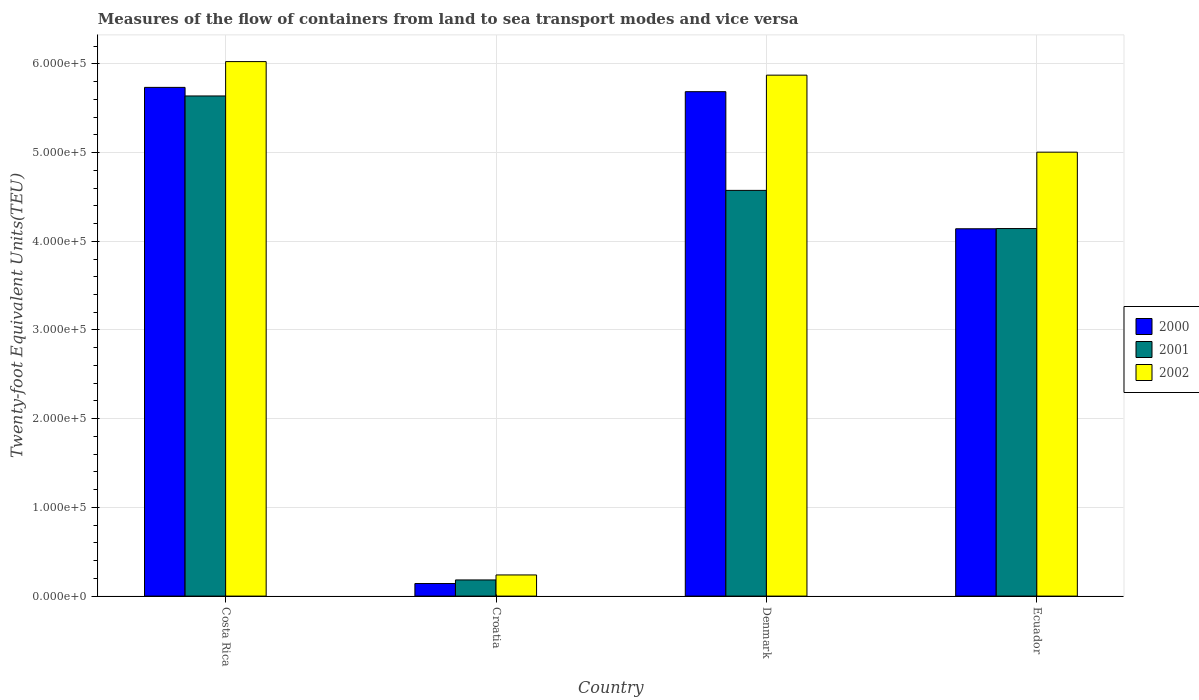How many different coloured bars are there?
Your answer should be very brief. 3. Are the number of bars on each tick of the X-axis equal?
Offer a very short reply. Yes. How many bars are there on the 2nd tick from the left?
Ensure brevity in your answer.  3. What is the label of the 1st group of bars from the left?
Provide a succinct answer. Costa Rica. In how many cases, is the number of bars for a given country not equal to the number of legend labels?
Give a very brief answer. 0. What is the container port traffic in 2000 in Costa Rica?
Your response must be concise. 5.74e+05. Across all countries, what is the maximum container port traffic in 2001?
Offer a very short reply. 5.64e+05. Across all countries, what is the minimum container port traffic in 2000?
Offer a very short reply. 1.42e+04. In which country was the container port traffic in 2000 maximum?
Provide a short and direct response. Costa Rica. In which country was the container port traffic in 2000 minimum?
Provide a succinct answer. Croatia. What is the total container port traffic in 2000 in the graph?
Offer a terse response. 1.57e+06. What is the difference between the container port traffic in 2002 in Croatia and that in Denmark?
Your answer should be very brief. -5.63e+05. What is the difference between the container port traffic in 2002 in Costa Rica and the container port traffic in 2001 in Croatia?
Provide a succinct answer. 5.84e+05. What is the average container port traffic in 2000 per country?
Ensure brevity in your answer.  3.93e+05. What is the difference between the container port traffic of/in 2002 and container port traffic of/in 2000 in Croatia?
Offer a very short reply. 9700. In how many countries, is the container port traffic in 2000 greater than 540000 TEU?
Your answer should be very brief. 2. What is the ratio of the container port traffic in 2001 in Croatia to that in Denmark?
Your answer should be compact. 0.04. Is the container port traffic in 2001 in Croatia less than that in Denmark?
Ensure brevity in your answer.  Yes. What is the difference between the highest and the second highest container port traffic in 2002?
Provide a succinct answer. 1.53e+04. What is the difference between the highest and the lowest container port traffic in 2000?
Ensure brevity in your answer.  5.59e+05. In how many countries, is the container port traffic in 2001 greater than the average container port traffic in 2001 taken over all countries?
Provide a succinct answer. 3. Is it the case that in every country, the sum of the container port traffic in 2002 and container port traffic in 2000 is greater than the container port traffic in 2001?
Your response must be concise. Yes. How many bars are there?
Your answer should be compact. 12. Are all the bars in the graph horizontal?
Give a very brief answer. No. How many countries are there in the graph?
Your response must be concise. 4. What is the difference between two consecutive major ticks on the Y-axis?
Ensure brevity in your answer.  1.00e+05. Are the values on the major ticks of Y-axis written in scientific E-notation?
Provide a succinct answer. Yes. Where does the legend appear in the graph?
Your response must be concise. Center right. How many legend labels are there?
Ensure brevity in your answer.  3. How are the legend labels stacked?
Make the answer very short. Vertical. What is the title of the graph?
Give a very brief answer. Measures of the flow of containers from land to sea transport modes and vice versa. Does "1992" appear as one of the legend labels in the graph?
Ensure brevity in your answer.  No. What is the label or title of the Y-axis?
Keep it short and to the point. Twenty-foot Equivalent Units(TEU). What is the Twenty-foot Equivalent Units(TEU) of 2000 in Costa Rica?
Make the answer very short. 5.74e+05. What is the Twenty-foot Equivalent Units(TEU) in 2001 in Costa Rica?
Offer a terse response. 5.64e+05. What is the Twenty-foot Equivalent Units(TEU) of 2002 in Costa Rica?
Make the answer very short. 6.03e+05. What is the Twenty-foot Equivalent Units(TEU) of 2000 in Croatia?
Your response must be concise. 1.42e+04. What is the Twenty-foot Equivalent Units(TEU) of 2001 in Croatia?
Give a very brief answer. 1.82e+04. What is the Twenty-foot Equivalent Units(TEU) in 2002 in Croatia?
Offer a very short reply. 2.39e+04. What is the Twenty-foot Equivalent Units(TEU) in 2000 in Denmark?
Provide a short and direct response. 5.69e+05. What is the Twenty-foot Equivalent Units(TEU) in 2001 in Denmark?
Your response must be concise. 4.57e+05. What is the Twenty-foot Equivalent Units(TEU) of 2002 in Denmark?
Provide a short and direct response. 5.87e+05. What is the Twenty-foot Equivalent Units(TEU) of 2000 in Ecuador?
Your answer should be very brief. 4.14e+05. What is the Twenty-foot Equivalent Units(TEU) of 2001 in Ecuador?
Ensure brevity in your answer.  4.14e+05. What is the Twenty-foot Equivalent Units(TEU) in 2002 in Ecuador?
Give a very brief answer. 5.00e+05. Across all countries, what is the maximum Twenty-foot Equivalent Units(TEU) of 2000?
Your answer should be very brief. 5.74e+05. Across all countries, what is the maximum Twenty-foot Equivalent Units(TEU) in 2001?
Offer a very short reply. 5.64e+05. Across all countries, what is the maximum Twenty-foot Equivalent Units(TEU) in 2002?
Give a very brief answer. 6.03e+05. Across all countries, what is the minimum Twenty-foot Equivalent Units(TEU) of 2000?
Offer a terse response. 1.42e+04. Across all countries, what is the minimum Twenty-foot Equivalent Units(TEU) of 2001?
Keep it short and to the point. 1.82e+04. Across all countries, what is the minimum Twenty-foot Equivalent Units(TEU) of 2002?
Your answer should be very brief. 2.39e+04. What is the total Twenty-foot Equivalent Units(TEU) in 2000 in the graph?
Your answer should be very brief. 1.57e+06. What is the total Twenty-foot Equivalent Units(TEU) in 2001 in the graph?
Offer a very short reply. 1.45e+06. What is the total Twenty-foot Equivalent Units(TEU) of 2002 in the graph?
Offer a terse response. 1.71e+06. What is the difference between the Twenty-foot Equivalent Units(TEU) in 2000 in Costa Rica and that in Croatia?
Make the answer very short. 5.59e+05. What is the difference between the Twenty-foot Equivalent Units(TEU) of 2001 in Costa Rica and that in Croatia?
Give a very brief answer. 5.46e+05. What is the difference between the Twenty-foot Equivalent Units(TEU) in 2002 in Costa Rica and that in Croatia?
Provide a short and direct response. 5.79e+05. What is the difference between the Twenty-foot Equivalent Units(TEU) of 2000 in Costa Rica and that in Denmark?
Keep it short and to the point. 4842. What is the difference between the Twenty-foot Equivalent Units(TEU) in 2001 in Costa Rica and that in Denmark?
Ensure brevity in your answer.  1.06e+05. What is the difference between the Twenty-foot Equivalent Units(TEU) in 2002 in Costa Rica and that in Denmark?
Make the answer very short. 1.53e+04. What is the difference between the Twenty-foot Equivalent Units(TEU) in 2000 in Costa Rica and that in Ecuador?
Provide a short and direct response. 1.59e+05. What is the difference between the Twenty-foot Equivalent Units(TEU) of 2001 in Costa Rica and that in Ecuador?
Offer a terse response. 1.49e+05. What is the difference between the Twenty-foot Equivalent Units(TEU) of 2002 in Costa Rica and that in Ecuador?
Your answer should be compact. 1.02e+05. What is the difference between the Twenty-foot Equivalent Units(TEU) in 2000 in Croatia and that in Denmark?
Your answer should be very brief. -5.55e+05. What is the difference between the Twenty-foot Equivalent Units(TEU) in 2001 in Croatia and that in Denmark?
Make the answer very short. -4.39e+05. What is the difference between the Twenty-foot Equivalent Units(TEU) of 2002 in Croatia and that in Denmark?
Your answer should be very brief. -5.63e+05. What is the difference between the Twenty-foot Equivalent Units(TEU) in 2000 in Croatia and that in Ecuador?
Your response must be concise. -4.00e+05. What is the difference between the Twenty-foot Equivalent Units(TEU) in 2001 in Croatia and that in Ecuador?
Provide a succinct answer. -3.96e+05. What is the difference between the Twenty-foot Equivalent Units(TEU) of 2002 in Croatia and that in Ecuador?
Your response must be concise. -4.77e+05. What is the difference between the Twenty-foot Equivalent Units(TEU) in 2000 in Denmark and that in Ecuador?
Make the answer very short. 1.55e+05. What is the difference between the Twenty-foot Equivalent Units(TEU) of 2001 in Denmark and that in Ecuador?
Provide a short and direct response. 4.30e+04. What is the difference between the Twenty-foot Equivalent Units(TEU) of 2002 in Denmark and that in Ecuador?
Ensure brevity in your answer.  8.68e+04. What is the difference between the Twenty-foot Equivalent Units(TEU) of 2000 in Costa Rica and the Twenty-foot Equivalent Units(TEU) of 2001 in Croatia?
Offer a very short reply. 5.55e+05. What is the difference between the Twenty-foot Equivalent Units(TEU) in 2000 in Costa Rica and the Twenty-foot Equivalent Units(TEU) in 2002 in Croatia?
Give a very brief answer. 5.50e+05. What is the difference between the Twenty-foot Equivalent Units(TEU) in 2001 in Costa Rica and the Twenty-foot Equivalent Units(TEU) in 2002 in Croatia?
Your answer should be very brief. 5.40e+05. What is the difference between the Twenty-foot Equivalent Units(TEU) in 2000 in Costa Rica and the Twenty-foot Equivalent Units(TEU) in 2001 in Denmark?
Ensure brevity in your answer.  1.16e+05. What is the difference between the Twenty-foot Equivalent Units(TEU) in 2000 in Costa Rica and the Twenty-foot Equivalent Units(TEU) in 2002 in Denmark?
Make the answer very short. -1.38e+04. What is the difference between the Twenty-foot Equivalent Units(TEU) in 2001 in Costa Rica and the Twenty-foot Equivalent Units(TEU) in 2002 in Denmark?
Offer a very short reply. -2.35e+04. What is the difference between the Twenty-foot Equivalent Units(TEU) of 2000 in Costa Rica and the Twenty-foot Equivalent Units(TEU) of 2001 in Ecuador?
Your response must be concise. 1.59e+05. What is the difference between the Twenty-foot Equivalent Units(TEU) in 2000 in Costa Rica and the Twenty-foot Equivalent Units(TEU) in 2002 in Ecuador?
Your answer should be compact. 7.30e+04. What is the difference between the Twenty-foot Equivalent Units(TEU) of 2001 in Costa Rica and the Twenty-foot Equivalent Units(TEU) of 2002 in Ecuador?
Ensure brevity in your answer.  6.34e+04. What is the difference between the Twenty-foot Equivalent Units(TEU) in 2000 in Croatia and the Twenty-foot Equivalent Units(TEU) in 2001 in Denmark?
Your response must be concise. -4.43e+05. What is the difference between the Twenty-foot Equivalent Units(TEU) of 2000 in Croatia and the Twenty-foot Equivalent Units(TEU) of 2002 in Denmark?
Give a very brief answer. -5.73e+05. What is the difference between the Twenty-foot Equivalent Units(TEU) of 2001 in Croatia and the Twenty-foot Equivalent Units(TEU) of 2002 in Denmark?
Make the answer very short. -5.69e+05. What is the difference between the Twenty-foot Equivalent Units(TEU) of 2000 in Croatia and the Twenty-foot Equivalent Units(TEU) of 2001 in Ecuador?
Make the answer very short. -4.00e+05. What is the difference between the Twenty-foot Equivalent Units(TEU) of 2000 in Croatia and the Twenty-foot Equivalent Units(TEU) of 2002 in Ecuador?
Make the answer very short. -4.86e+05. What is the difference between the Twenty-foot Equivalent Units(TEU) in 2001 in Croatia and the Twenty-foot Equivalent Units(TEU) in 2002 in Ecuador?
Ensure brevity in your answer.  -4.82e+05. What is the difference between the Twenty-foot Equivalent Units(TEU) of 2000 in Denmark and the Twenty-foot Equivalent Units(TEU) of 2001 in Ecuador?
Your answer should be compact. 1.54e+05. What is the difference between the Twenty-foot Equivalent Units(TEU) of 2000 in Denmark and the Twenty-foot Equivalent Units(TEU) of 2002 in Ecuador?
Provide a short and direct response. 6.82e+04. What is the difference between the Twenty-foot Equivalent Units(TEU) in 2001 in Denmark and the Twenty-foot Equivalent Units(TEU) in 2002 in Ecuador?
Keep it short and to the point. -4.31e+04. What is the average Twenty-foot Equivalent Units(TEU) of 2000 per country?
Provide a short and direct response. 3.93e+05. What is the average Twenty-foot Equivalent Units(TEU) in 2001 per country?
Give a very brief answer. 3.63e+05. What is the average Twenty-foot Equivalent Units(TEU) in 2002 per country?
Your answer should be compact. 4.29e+05. What is the difference between the Twenty-foot Equivalent Units(TEU) in 2000 and Twenty-foot Equivalent Units(TEU) in 2001 in Costa Rica?
Offer a terse response. 9677. What is the difference between the Twenty-foot Equivalent Units(TEU) of 2000 and Twenty-foot Equivalent Units(TEU) of 2002 in Costa Rica?
Ensure brevity in your answer.  -2.91e+04. What is the difference between the Twenty-foot Equivalent Units(TEU) in 2001 and Twenty-foot Equivalent Units(TEU) in 2002 in Costa Rica?
Ensure brevity in your answer.  -3.87e+04. What is the difference between the Twenty-foot Equivalent Units(TEU) of 2000 and Twenty-foot Equivalent Units(TEU) of 2001 in Croatia?
Make the answer very short. -4065. What is the difference between the Twenty-foot Equivalent Units(TEU) in 2000 and Twenty-foot Equivalent Units(TEU) in 2002 in Croatia?
Offer a very short reply. -9700. What is the difference between the Twenty-foot Equivalent Units(TEU) in 2001 and Twenty-foot Equivalent Units(TEU) in 2002 in Croatia?
Keep it short and to the point. -5635. What is the difference between the Twenty-foot Equivalent Units(TEU) of 2000 and Twenty-foot Equivalent Units(TEU) of 2001 in Denmark?
Make the answer very short. 1.11e+05. What is the difference between the Twenty-foot Equivalent Units(TEU) in 2000 and Twenty-foot Equivalent Units(TEU) in 2002 in Denmark?
Provide a short and direct response. -1.86e+04. What is the difference between the Twenty-foot Equivalent Units(TEU) of 2001 and Twenty-foot Equivalent Units(TEU) of 2002 in Denmark?
Offer a very short reply. -1.30e+05. What is the difference between the Twenty-foot Equivalent Units(TEU) in 2000 and Twenty-foot Equivalent Units(TEU) in 2001 in Ecuador?
Provide a succinct answer. -251. What is the difference between the Twenty-foot Equivalent Units(TEU) in 2000 and Twenty-foot Equivalent Units(TEU) in 2002 in Ecuador?
Provide a succinct answer. -8.64e+04. What is the difference between the Twenty-foot Equivalent Units(TEU) of 2001 and Twenty-foot Equivalent Units(TEU) of 2002 in Ecuador?
Make the answer very short. -8.61e+04. What is the ratio of the Twenty-foot Equivalent Units(TEU) of 2000 in Costa Rica to that in Croatia?
Provide a succinct answer. 40.52. What is the ratio of the Twenty-foot Equivalent Units(TEU) in 2001 in Costa Rica to that in Croatia?
Keep it short and to the point. 30.95. What is the ratio of the Twenty-foot Equivalent Units(TEU) in 2002 in Costa Rica to that in Croatia?
Offer a terse response. 25.26. What is the ratio of the Twenty-foot Equivalent Units(TEU) in 2000 in Costa Rica to that in Denmark?
Your answer should be compact. 1.01. What is the ratio of the Twenty-foot Equivalent Units(TEU) of 2001 in Costa Rica to that in Denmark?
Provide a succinct answer. 1.23. What is the ratio of the Twenty-foot Equivalent Units(TEU) of 2002 in Costa Rica to that in Denmark?
Provide a short and direct response. 1.03. What is the ratio of the Twenty-foot Equivalent Units(TEU) in 2000 in Costa Rica to that in Ecuador?
Provide a succinct answer. 1.38. What is the ratio of the Twenty-foot Equivalent Units(TEU) in 2001 in Costa Rica to that in Ecuador?
Offer a terse response. 1.36. What is the ratio of the Twenty-foot Equivalent Units(TEU) in 2002 in Costa Rica to that in Ecuador?
Offer a terse response. 1.2. What is the ratio of the Twenty-foot Equivalent Units(TEU) of 2000 in Croatia to that in Denmark?
Keep it short and to the point. 0.02. What is the ratio of the Twenty-foot Equivalent Units(TEU) in 2001 in Croatia to that in Denmark?
Your response must be concise. 0.04. What is the ratio of the Twenty-foot Equivalent Units(TEU) in 2002 in Croatia to that in Denmark?
Offer a very short reply. 0.04. What is the ratio of the Twenty-foot Equivalent Units(TEU) in 2000 in Croatia to that in Ecuador?
Provide a short and direct response. 0.03. What is the ratio of the Twenty-foot Equivalent Units(TEU) of 2001 in Croatia to that in Ecuador?
Make the answer very short. 0.04. What is the ratio of the Twenty-foot Equivalent Units(TEU) of 2002 in Croatia to that in Ecuador?
Provide a succinct answer. 0.05. What is the ratio of the Twenty-foot Equivalent Units(TEU) of 2000 in Denmark to that in Ecuador?
Your response must be concise. 1.37. What is the ratio of the Twenty-foot Equivalent Units(TEU) of 2001 in Denmark to that in Ecuador?
Ensure brevity in your answer.  1.1. What is the ratio of the Twenty-foot Equivalent Units(TEU) in 2002 in Denmark to that in Ecuador?
Make the answer very short. 1.17. What is the difference between the highest and the second highest Twenty-foot Equivalent Units(TEU) in 2000?
Ensure brevity in your answer.  4842. What is the difference between the highest and the second highest Twenty-foot Equivalent Units(TEU) in 2001?
Ensure brevity in your answer.  1.06e+05. What is the difference between the highest and the second highest Twenty-foot Equivalent Units(TEU) of 2002?
Your response must be concise. 1.53e+04. What is the difference between the highest and the lowest Twenty-foot Equivalent Units(TEU) of 2000?
Give a very brief answer. 5.59e+05. What is the difference between the highest and the lowest Twenty-foot Equivalent Units(TEU) of 2001?
Your response must be concise. 5.46e+05. What is the difference between the highest and the lowest Twenty-foot Equivalent Units(TEU) in 2002?
Provide a short and direct response. 5.79e+05. 